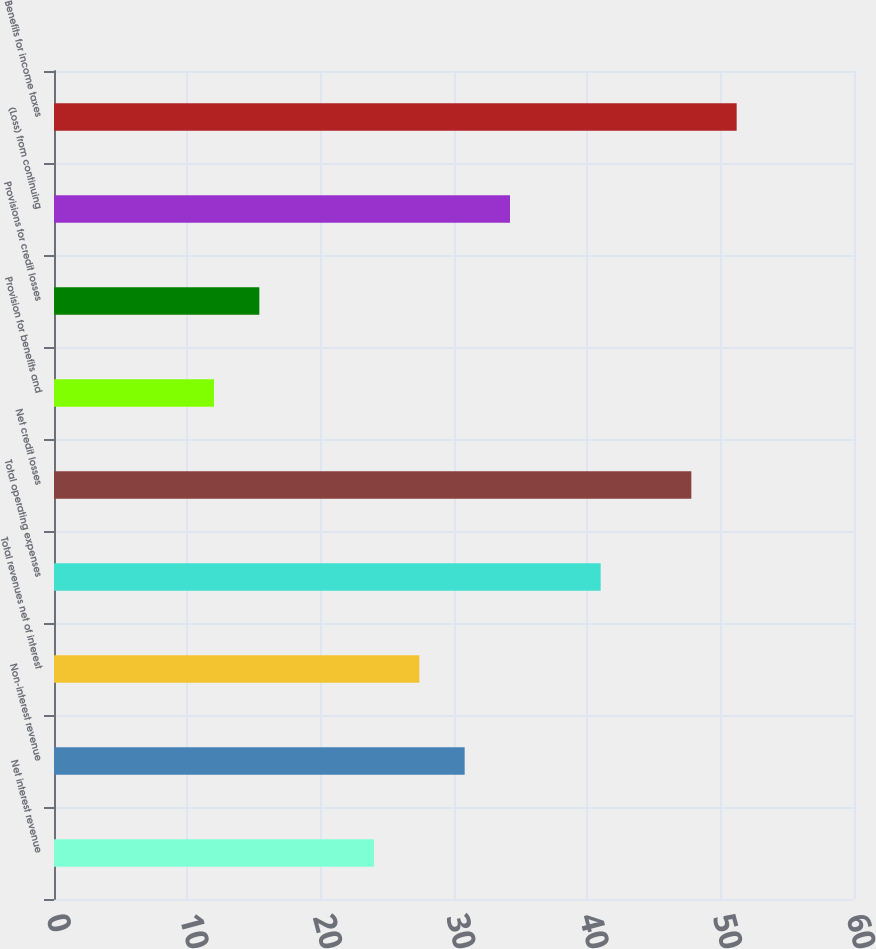<chart> <loc_0><loc_0><loc_500><loc_500><bar_chart><fcel>Net interest revenue<fcel>Non-interest revenue<fcel>Total revenues net of interest<fcel>Total operating expenses<fcel>Net credit losses<fcel>Provision for benefits and<fcel>Provisions for credit losses<fcel>(Loss) from continuing<fcel>Benefits for income taxes<nl><fcel>24<fcel>30.8<fcel>27.4<fcel>41<fcel>47.8<fcel>12<fcel>15.4<fcel>34.2<fcel>51.2<nl></chart> 